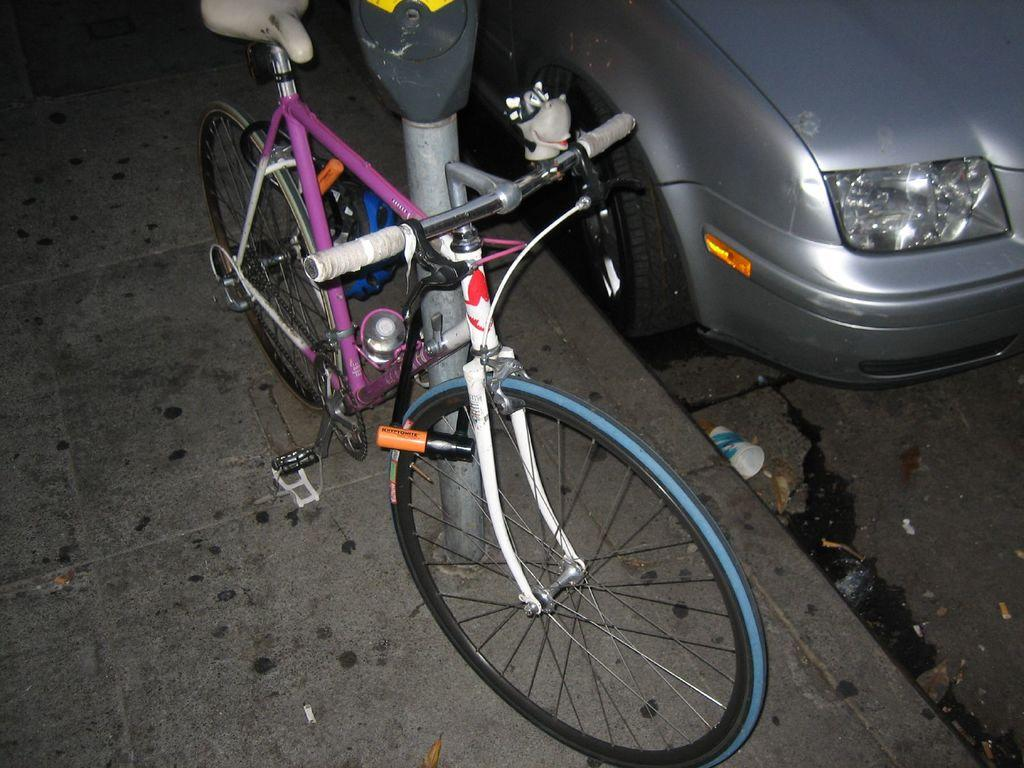What is the main mode of transportation visible in the image? There is a bicycle in the image. What else can be seen on the footpath in the image? There is a pole on the footpath in the image. What is on the road in the image? There is a car and a cup on the road in the image. What year is depicted in the image? The image does not depict a specific year; it is a snapshot of a scene with a bicycle, pole, car, and cup. 